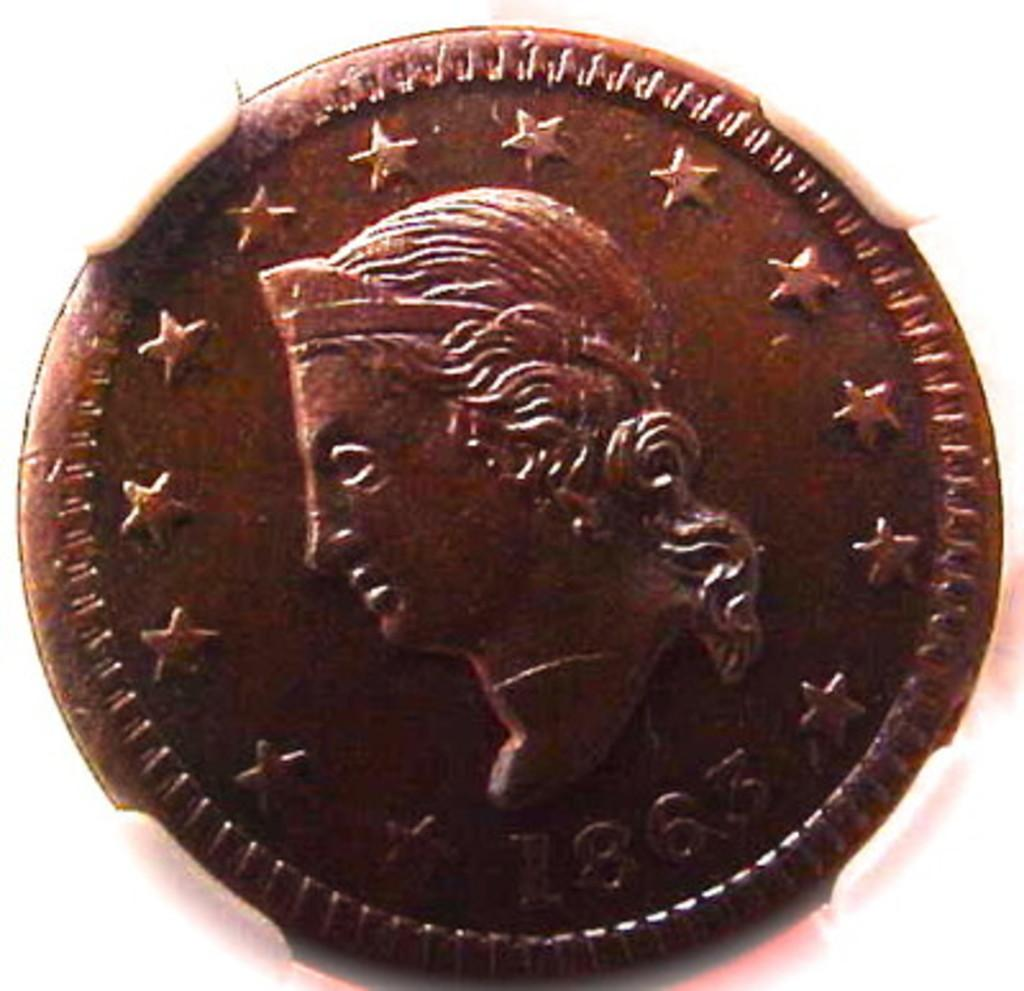<image>
Relay a brief, clear account of the picture shown. A copper coin that has the date 1863 at the bottom. 